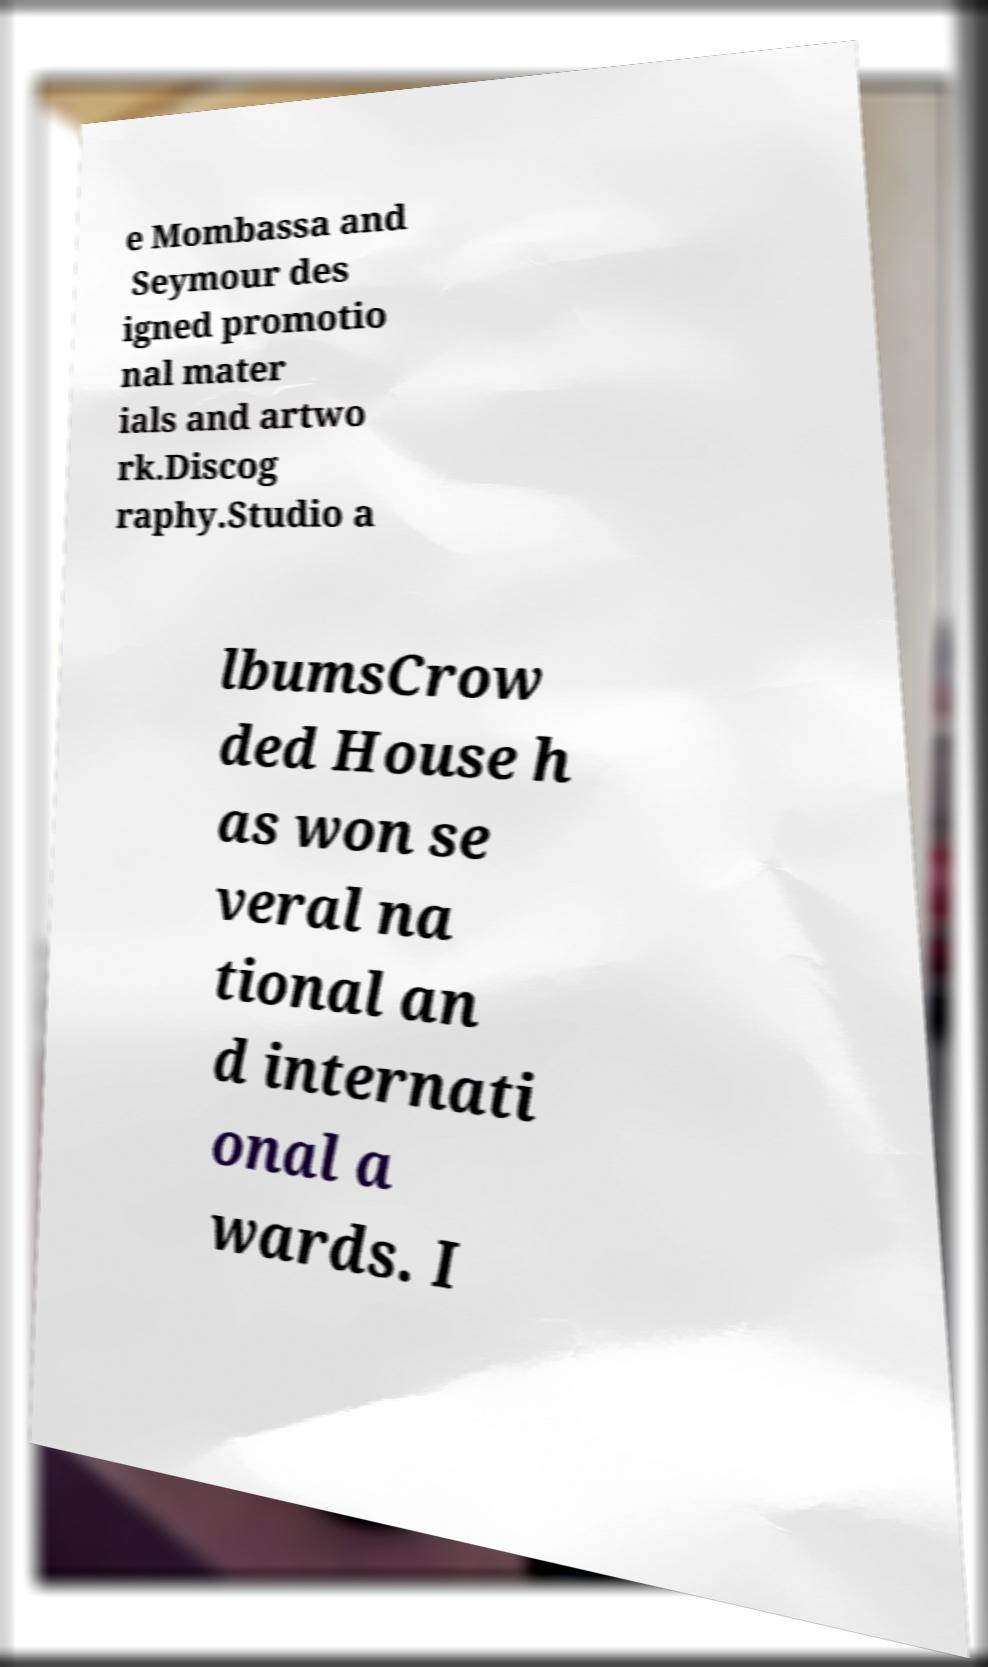Please identify and transcribe the text found in this image. e Mombassa and Seymour des igned promotio nal mater ials and artwo rk.Discog raphy.Studio a lbumsCrow ded House h as won se veral na tional an d internati onal a wards. I 